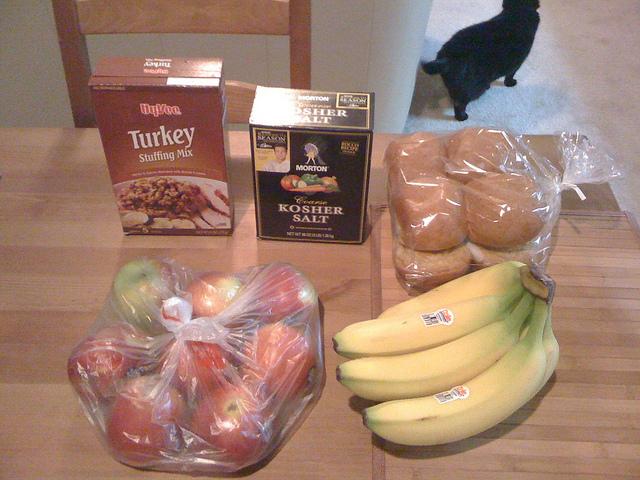What kind of bird is mentioned on box on left?
Write a very short answer. Turkey. How many bananas have stickers on them?
Concise answer only. 2. What is the item on the top right?
Concise answer only. Buns. 